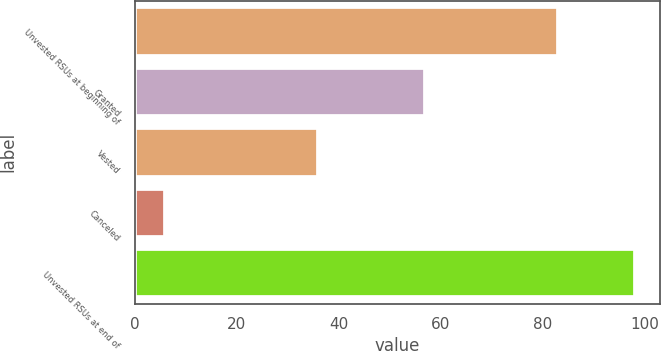Convert chart. <chart><loc_0><loc_0><loc_500><loc_500><bar_chart><fcel>Unvested RSUs at beginning of<fcel>Granted<fcel>Vested<fcel>Canceled<fcel>Unvested RSUs at end of<nl><fcel>83<fcel>57<fcel>36<fcel>6<fcel>98<nl></chart> 